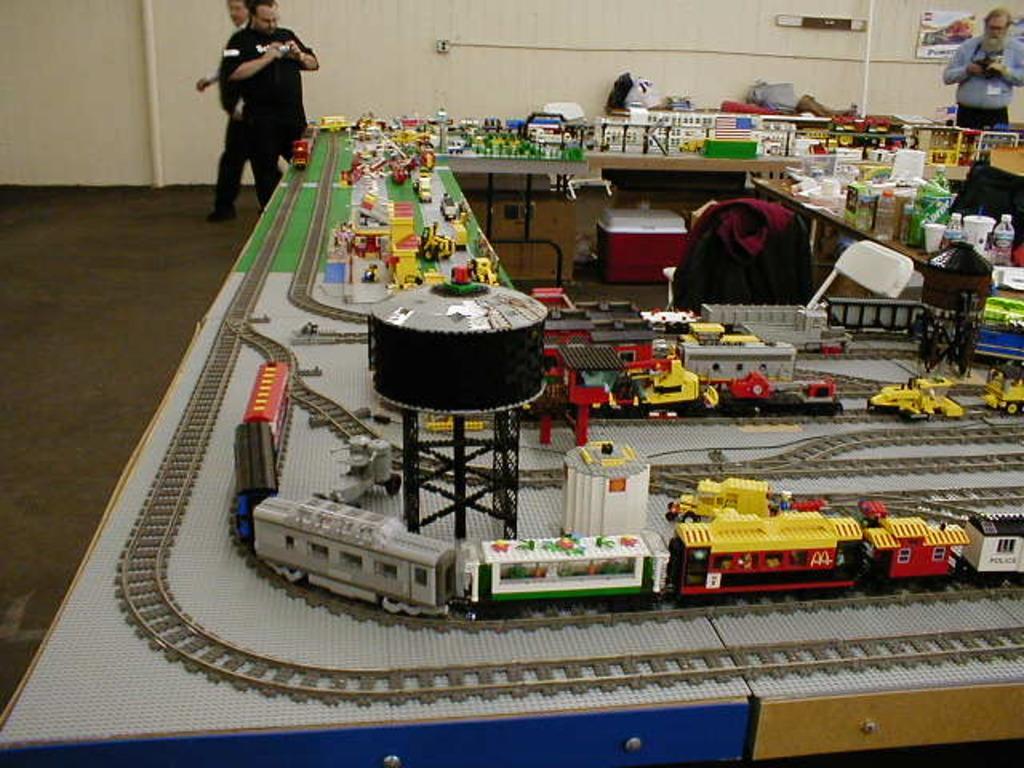Can you describe this image briefly? In the center of the image we can see many toy trains, blocks, bottles, chair, bag and container. In the background there are persons and wall. 